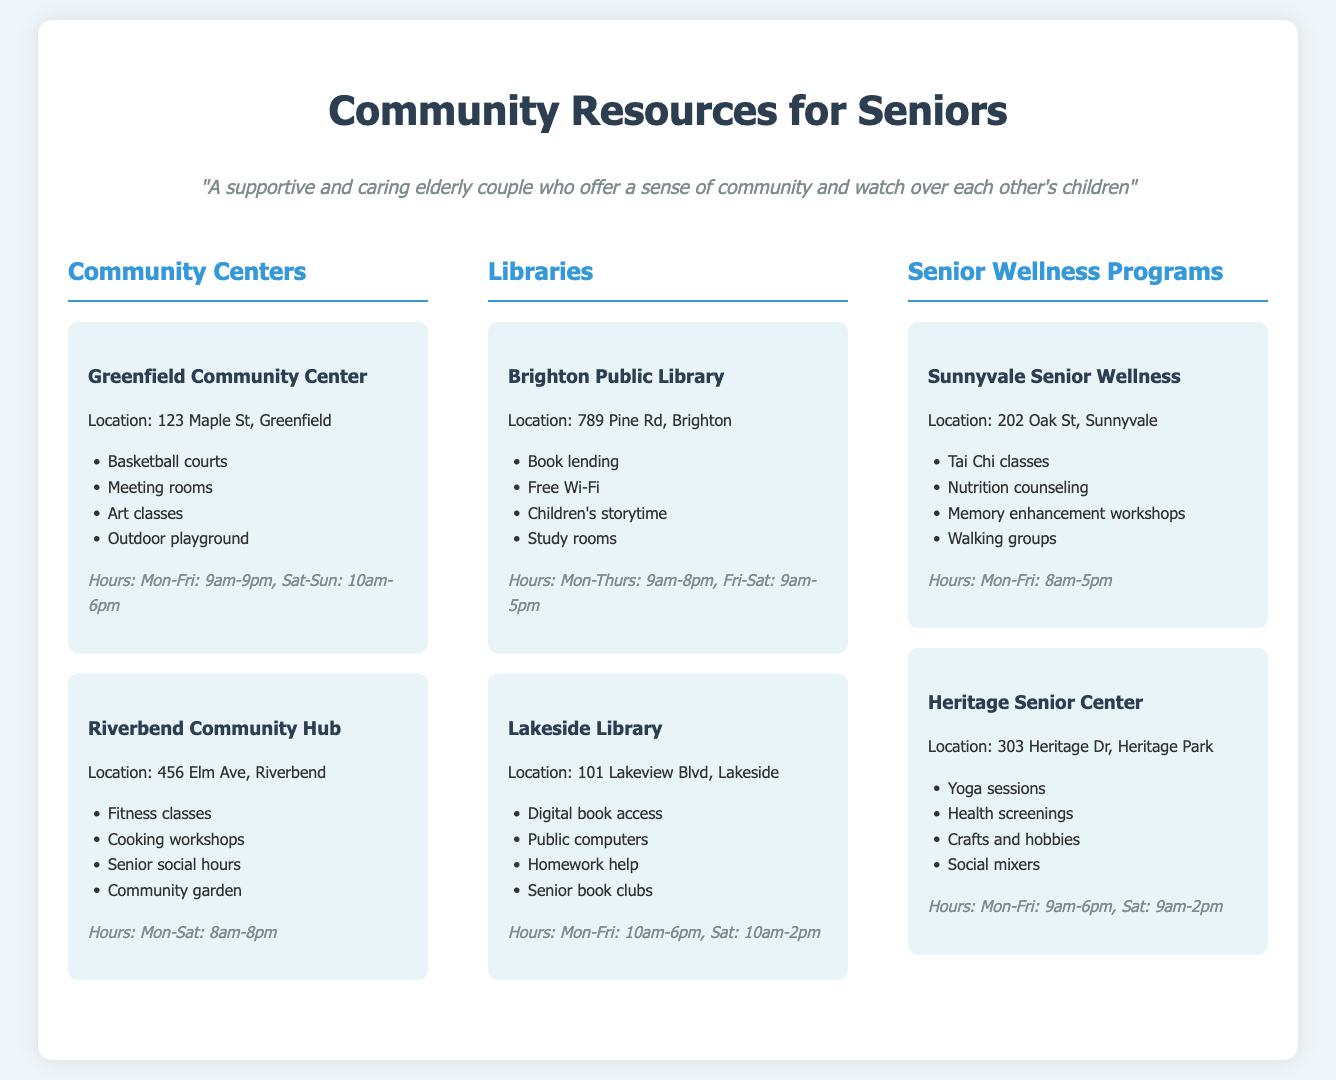What is the location of the Greenfield Community Center? The location is mentioned directly in the document.
Answer: 123 Maple St, Greenfield What hours is the Lakeside Library open on Saturdays? The hours for Lakeside Library are provided specifically in the document.
Answer: 10am-2pm Which community center offers cooking workshops? The document lists various offerings at community centers, indicating which programs are available.
Answer: Riverbend Community Hub How many senior wellness programs are listed in the document? The document explicitly states the number of different senior wellness programs available.
Answer: 2 What type of classes can you find at Heritage Senior Center? The document outlines the activities offered at Heritage Senior Center, summarizing its program type.
Answer: Yoga sessions What is a service provided by Brighton Public Library? The document provides a list of services at Brighton Public Library for easy identification.
Answer: Book lending What common feature is available at both community centers mentioned? The document encourages reasoning across the different offerings at community centers.
Answer: Meeting rooms 